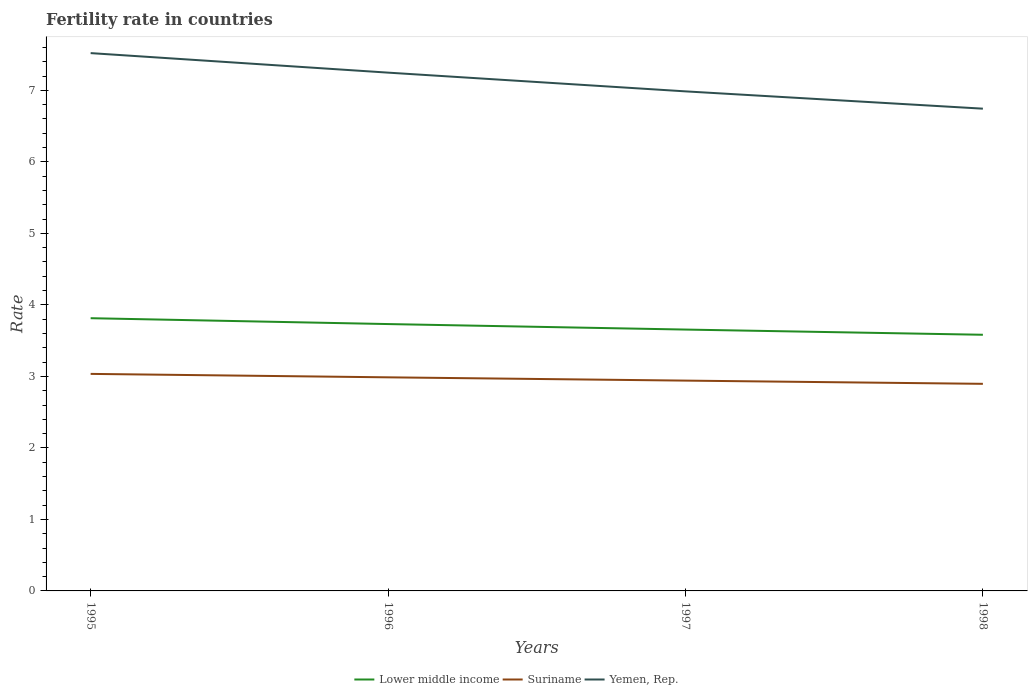How many different coloured lines are there?
Offer a very short reply. 3. Does the line corresponding to Lower middle income intersect with the line corresponding to Suriname?
Make the answer very short. No. Is the number of lines equal to the number of legend labels?
Offer a very short reply. Yes. Across all years, what is the maximum fertility rate in Lower middle income?
Your answer should be very brief. 3.58. In which year was the fertility rate in Suriname maximum?
Your response must be concise. 1998. What is the total fertility rate in Suriname in the graph?
Offer a very short reply. 0.04. What is the difference between the highest and the second highest fertility rate in Yemen, Rep.?
Give a very brief answer. 0.78. What is the difference between the highest and the lowest fertility rate in Lower middle income?
Offer a terse response. 2. How many lines are there?
Provide a succinct answer. 3. What is the difference between two consecutive major ticks on the Y-axis?
Your response must be concise. 1. How many legend labels are there?
Offer a very short reply. 3. How are the legend labels stacked?
Provide a short and direct response. Horizontal. What is the title of the graph?
Your answer should be very brief. Fertility rate in countries. What is the label or title of the X-axis?
Make the answer very short. Years. What is the label or title of the Y-axis?
Provide a succinct answer. Rate. What is the Rate in Lower middle income in 1995?
Give a very brief answer. 3.81. What is the Rate in Suriname in 1995?
Your answer should be compact. 3.04. What is the Rate of Yemen, Rep. in 1995?
Give a very brief answer. 7.52. What is the Rate in Lower middle income in 1996?
Keep it short and to the point. 3.73. What is the Rate of Suriname in 1996?
Provide a succinct answer. 2.99. What is the Rate in Yemen, Rep. in 1996?
Keep it short and to the point. 7.25. What is the Rate in Lower middle income in 1997?
Give a very brief answer. 3.66. What is the Rate of Suriname in 1997?
Your response must be concise. 2.94. What is the Rate of Yemen, Rep. in 1997?
Ensure brevity in your answer.  6.99. What is the Rate in Lower middle income in 1998?
Give a very brief answer. 3.58. What is the Rate of Suriname in 1998?
Provide a short and direct response. 2.9. What is the Rate of Yemen, Rep. in 1998?
Your answer should be compact. 6.74. Across all years, what is the maximum Rate of Lower middle income?
Provide a short and direct response. 3.81. Across all years, what is the maximum Rate in Suriname?
Provide a short and direct response. 3.04. Across all years, what is the maximum Rate in Yemen, Rep.?
Give a very brief answer. 7.52. Across all years, what is the minimum Rate in Lower middle income?
Ensure brevity in your answer.  3.58. Across all years, what is the minimum Rate of Suriname?
Your answer should be compact. 2.9. Across all years, what is the minimum Rate in Yemen, Rep.?
Provide a short and direct response. 6.74. What is the total Rate of Lower middle income in the graph?
Offer a very short reply. 14.78. What is the total Rate of Suriname in the graph?
Your answer should be compact. 11.86. What is the total Rate of Yemen, Rep. in the graph?
Provide a short and direct response. 28.5. What is the difference between the Rate in Lower middle income in 1995 and that in 1996?
Your response must be concise. 0.08. What is the difference between the Rate in Suriname in 1995 and that in 1996?
Provide a short and direct response. 0.05. What is the difference between the Rate of Yemen, Rep. in 1995 and that in 1996?
Keep it short and to the point. 0.27. What is the difference between the Rate of Lower middle income in 1995 and that in 1997?
Ensure brevity in your answer.  0.16. What is the difference between the Rate of Suriname in 1995 and that in 1997?
Provide a succinct answer. 0.09. What is the difference between the Rate in Yemen, Rep. in 1995 and that in 1997?
Provide a short and direct response. 0.54. What is the difference between the Rate in Lower middle income in 1995 and that in 1998?
Keep it short and to the point. 0.23. What is the difference between the Rate of Suriname in 1995 and that in 1998?
Ensure brevity in your answer.  0.14. What is the difference between the Rate in Yemen, Rep. in 1995 and that in 1998?
Provide a succinct answer. 0.78. What is the difference between the Rate in Lower middle income in 1996 and that in 1997?
Keep it short and to the point. 0.08. What is the difference between the Rate of Suriname in 1996 and that in 1997?
Keep it short and to the point. 0.05. What is the difference between the Rate of Yemen, Rep. in 1996 and that in 1997?
Ensure brevity in your answer.  0.26. What is the difference between the Rate of Lower middle income in 1996 and that in 1998?
Keep it short and to the point. 0.15. What is the difference between the Rate in Suriname in 1996 and that in 1998?
Keep it short and to the point. 0.09. What is the difference between the Rate of Yemen, Rep. in 1996 and that in 1998?
Keep it short and to the point. 0.5. What is the difference between the Rate of Lower middle income in 1997 and that in 1998?
Keep it short and to the point. 0.07. What is the difference between the Rate of Suriname in 1997 and that in 1998?
Keep it short and to the point. 0.04. What is the difference between the Rate in Yemen, Rep. in 1997 and that in 1998?
Your answer should be compact. 0.24. What is the difference between the Rate in Lower middle income in 1995 and the Rate in Suriname in 1996?
Offer a very short reply. 0.83. What is the difference between the Rate in Lower middle income in 1995 and the Rate in Yemen, Rep. in 1996?
Ensure brevity in your answer.  -3.43. What is the difference between the Rate of Suriname in 1995 and the Rate of Yemen, Rep. in 1996?
Your answer should be very brief. -4.21. What is the difference between the Rate in Lower middle income in 1995 and the Rate in Suriname in 1997?
Make the answer very short. 0.87. What is the difference between the Rate of Lower middle income in 1995 and the Rate of Yemen, Rep. in 1997?
Ensure brevity in your answer.  -3.17. What is the difference between the Rate in Suriname in 1995 and the Rate in Yemen, Rep. in 1997?
Give a very brief answer. -3.95. What is the difference between the Rate of Lower middle income in 1995 and the Rate of Suriname in 1998?
Provide a short and direct response. 0.92. What is the difference between the Rate in Lower middle income in 1995 and the Rate in Yemen, Rep. in 1998?
Your answer should be compact. -2.93. What is the difference between the Rate in Suriname in 1995 and the Rate in Yemen, Rep. in 1998?
Make the answer very short. -3.71. What is the difference between the Rate in Lower middle income in 1996 and the Rate in Suriname in 1997?
Make the answer very short. 0.79. What is the difference between the Rate in Lower middle income in 1996 and the Rate in Yemen, Rep. in 1997?
Your response must be concise. -3.25. What is the difference between the Rate in Suriname in 1996 and the Rate in Yemen, Rep. in 1997?
Your answer should be compact. -4. What is the difference between the Rate in Lower middle income in 1996 and the Rate in Suriname in 1998?
Your answer should be very brief. 0.84. What is the difference between the Rate in Lower middle income in 1996 and the Rate in Yemen, Rep. in 1998?
Give a very brief answer. -3.01. What is the difference between the Rate of Suriname in 1996 and the Rate of Yemen, Rep. in 1998?
Provide a succinct answer. -3.76. What is the difference between the Rate in Lower middle income in 1997 and the Rate in Suriname in 1998?
Your answer should be very brief. 0.76. What is the difference between the Rate in Lower middle income in 1997 and the Rate in Yemen, Rep. in 1998?
Provide a succinct answer. -3.09. What is the difference between the Rate in Suriname in 1997 and the Rate in Yemen, Rep. in 1998?
Your answer should be compact. -3.8. What is the average Rate of Lower middle income per year?
Your answer should be compact. 3.7. What is the average Rate in Suriname per year?
Ensure brevity in your answer.  2.96. What is the average Rate of Yemen, Rep. per year?
Your answer should be very brief. 7.12. In the year 1995, what is the difference between the Rate in Lower middle income and Rate in Suriname?
Keep it short and to the point. 0.78. In the year 1995, what is the difference between the Rate in Lower middle income and Rate in Yemen, Rep.?
Your answer should be compact. -3.71. In the year 1995, what is the difference between the Rate in Suriname and Rate in Yemen, Rep.?
Make the answer very short. -4.49. In the year 1996, what is the difference between the Rate in Lower middle income and Rate in Suriname?
Make the answer very short. 0.74. In the year 1996, what is the difference between the Rate in Lower middle income and Rate in Yemen, Rep.?
Your response must be concise. -3.52. In the year 1996, what is the difference between the Rate in Suriname and Rate in Yemen, Rep.?
Make the answer very short. -4.26. In the year 1997, what is the difference between the Rate of Lower middle income and Rate of Suriname?
Ensure brevity in your answer.  0.71. In the year 1997, what is the difference between the Rate in Lower middle income and Rate in Yemen, Rep.?
Offer a very short reply. -3.33. In the year 1997, what is the difference between the Rate in Suriname and Rate in Yemen, Rep.?
Keep it short and to the point. -4.04. In the year 1998, what is the difference between the Rate of Lower middle income and Rate of Suriname?
Provide a succinct answer. 0.69. In the year 1998, what is the difference between the Rate in Lower middle income and Rate in Yemen, Rep.?
Your response must be concise. -3.16. In the year 1998, what is the difference between the Rate in Suriname and Rate in Yemen, Rep.?
Offer a terse response. -3.85. What is the ratio of the Rate in Lower middle income in 1995 to that in 1996?
Make the answer very short. 1.02. What is the ratio of the Rate in Suriname in 1995 to that in 1996?
Offer a terse response. 1.02. What is the ratio of the Rate in Yemen, Rep. in 1995 to that in 1996?
Give a very brief answer. 1.04. What is the ratio of the Rate in Lower middle income in 1995 to that in 1997?
Offer a terse response. 1.04. What is the ratio of the Rate in Suriname in 1995 to that in 1997?
Provide a succinct answer. 1.03. What is the ratio of the Rate in Yemen, Rep. in 1995 to that in 1997?
Make the answer very short. 1.08. What is the ratio of the Rate in Lower middle income in 1995 to that in 1998?
Make the answer very short. 1.06. What is the ratio of the Rate of Suriname in 1995 to that in 1998?
Provide a short and direct response. 1.05. What is the ratio of the Rate in Yemen, Rep. in 1995 to that in 1998?
Keep it short and to the point. 1.12. What is the ratio of the Rate in Suriname in 1996 to that in 1997?
Offer a terse response. 1.02. What is the ratio of the Rate of Yemen, Rep. in 1996 to that in 1997?
Offer a terse response. 1.04. What is the ratio of the Rate in Lower middle income in 1996 to that in 1998?
Offer a very short reply. 1.04. What is the ratio of the Rate of Suriname in 1996 to that in 1998?
Your response must be concise. 1.03. What is the ratio of the Rate in Yemen, Rep. in 1996 to that in 1998?
Offer a terse response. 1.07. What is the ratio of the Rate in Lower middle income in 1997 to that in 1998?
Keep it short and to the point. 1.02. What is the ratio of the Rate in Suriname in 1997 to that in 1998?
Offer a very short reply. 1.02. What is the ratio of the Rate of Yemen, Rep. in 1997 to that in 1998?
Make the answer very short. 1.04. What is the difference between the highest and the second highest Rate in Lower middle income?
Provide a succinct answer. 0.08. What is the difference between the highest and the second highest Rate in Suriname?
Your answer should be compact. 0.05. What is the difference between the highest and the second highest Rate in Yemen, Rep.?
Make the answer very short. 0.27. What is the difference between the highest and the lowest Rate of Lower middle income?
Ensure brevity in your answer.  0.23. What is the difference between the highest and the lowest Rate in Suriname?
Offer a very short reply. 0.14. What is the difference between the highest and the lowest Rate in Yemen, Rep.?
Your response must be concise. 0.78. 